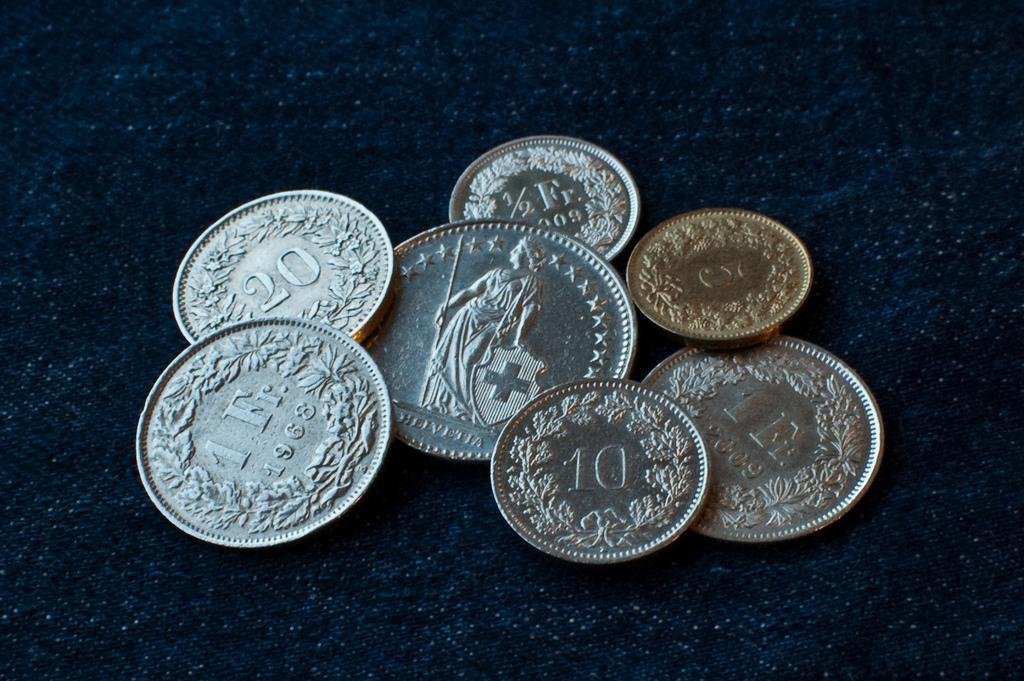What objects are present in the image? There are coins in the image. How are the coins arranged or placed? The coins are placed on a cloth. What color is the cloth on which the coins are placed? The cloth is blue in color. What type of pan is hanging on the wall in the image? There is no pan present in the image; it only features coins placed on a blue cloth. 